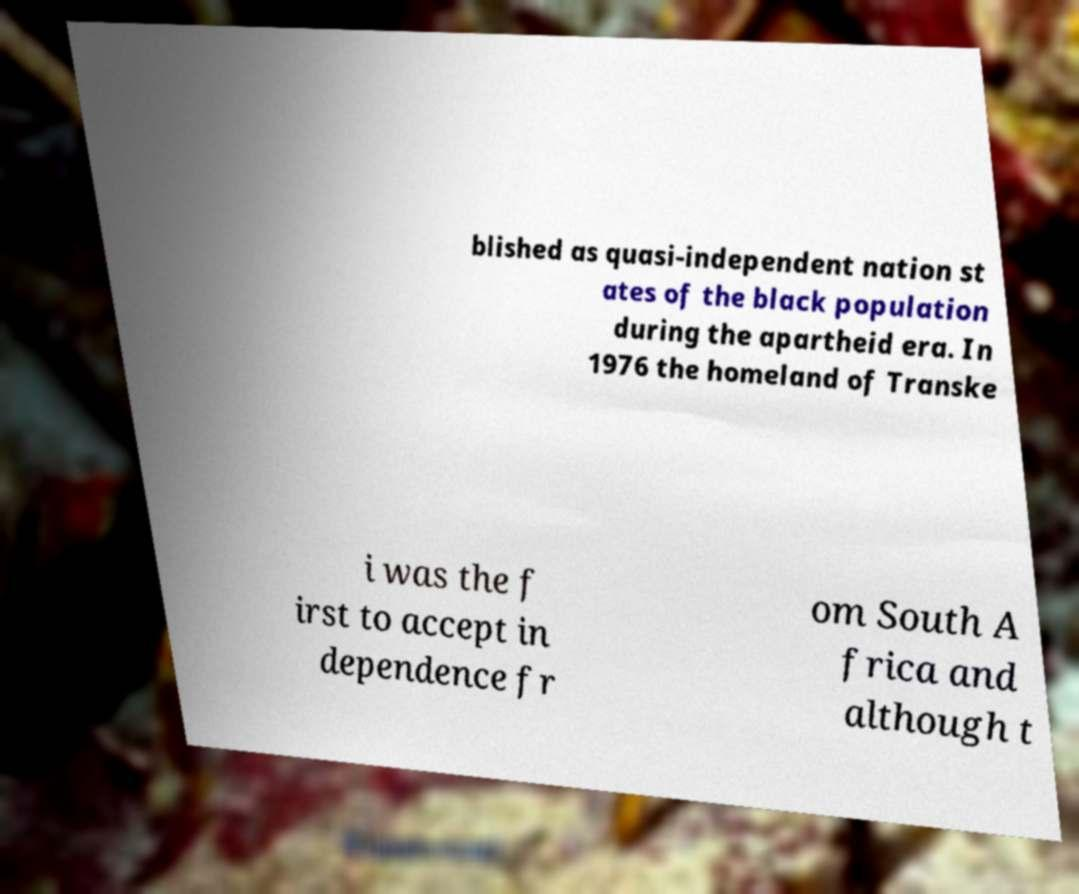For documentation purposes, I need the text within this image transcribed. Could you provide that? blished as quasi-independent nation st ates of the black population during the apartheid era. In 1976 the homeland of Transke i was the f irst to accept in dependence fr om South A frica and although t 